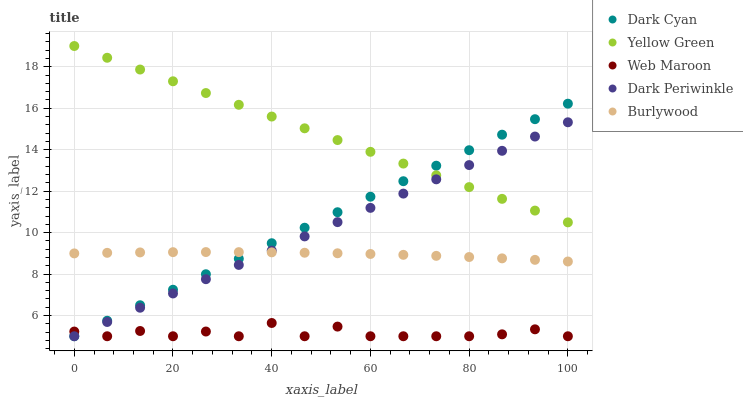Does Web Maroon have the minimum area under the curve?
Answer yes or no. Yes. Does Yellow Green have the maximum area under the curve?
Answer yes or no. Yes. Does Burlywood have the minimum area under the curve?
Answer yes or no. No. Does Burlywood have the maximum area under the curve?
Answer yes or no. No. Is Dark Cyan the smoothest?
Answer yes or no. Yes. Is Web Maroon the roughest?
Answer yes or no. Yes. Is Burlywood the smoothest?
Answer yes or no. No. Is Burlywood the roughest?
Answer yes or no. No. Does Dark Cyan have the lowest value?
Answer yes or no. Yes. Does Burlywood have the lowest value?
Answer yes or no. No. Does Yellow Green have the highest value?
Answer yes or no. Yes. Does Burlywood have the highest value?
Answer yes or no. No. Is Web Maroon less than Yellow Green?
Answer yes or no. Yes. Is Yellow Green greater than Burlywood?
Answer yes or no. Yes. Does Dark Periwinkle intersect Web Maroon?
Answer yes or no. Yes. Is Dark Periwinkle less than Web Maroon?
Answer yes or no. No. Is Dark Periwinkle greater than Web Maroon?
Answer yes or no. No. Does Web Maroon intersect Yellow Green?
Answer yes or no. No. 